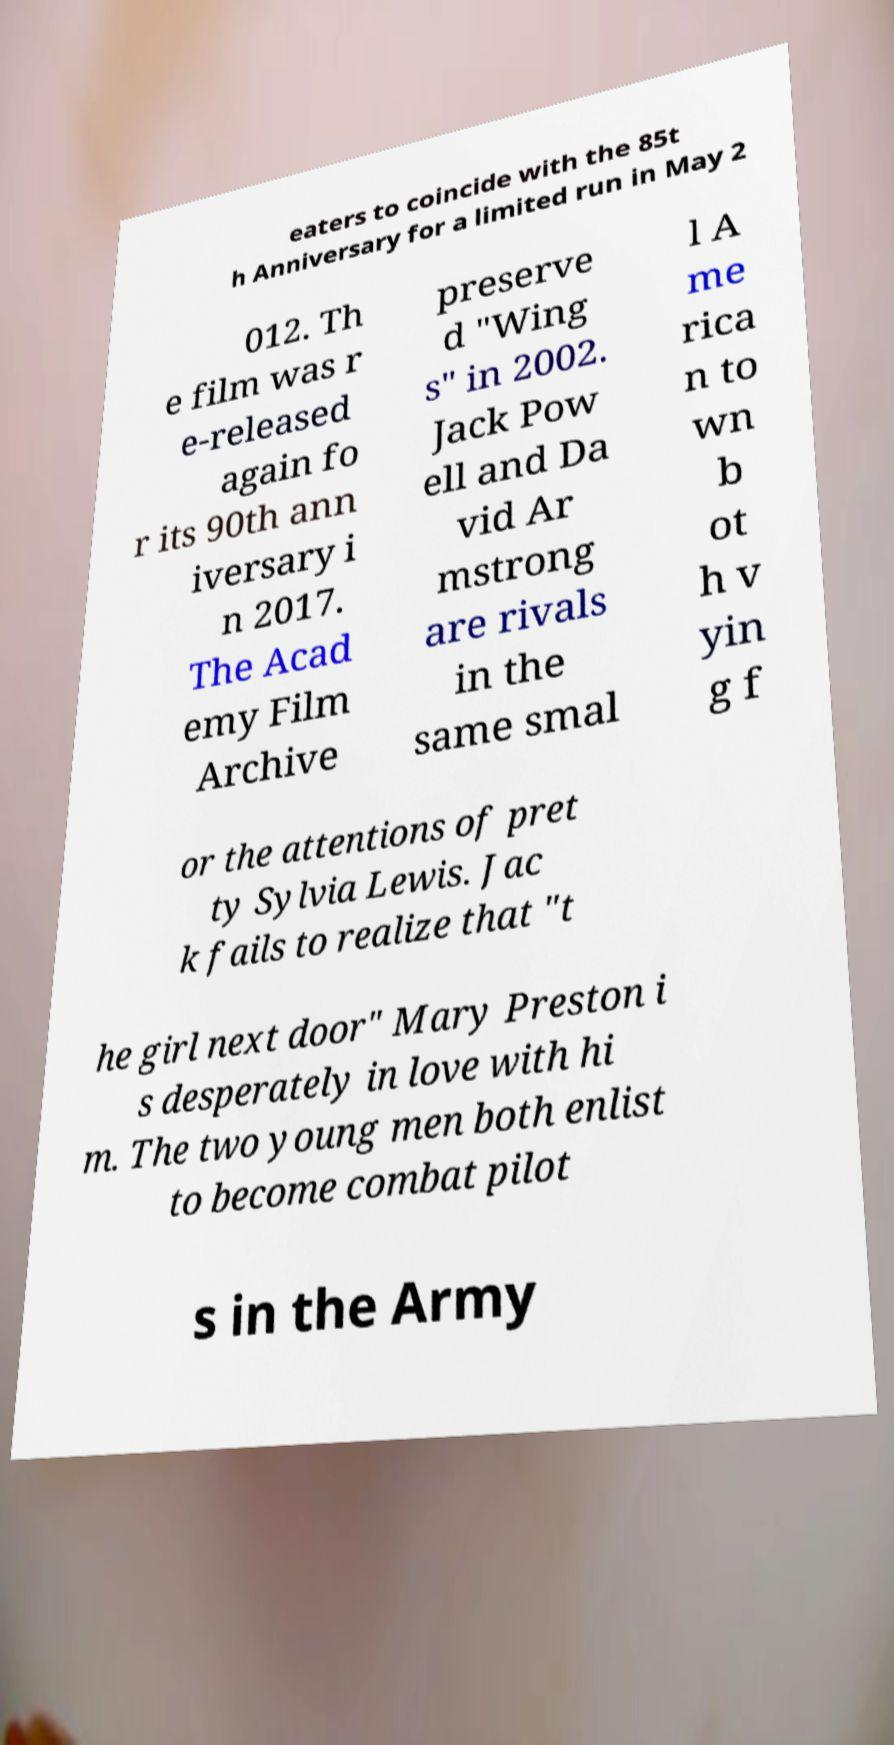What messages or text are displayed in this image? I need them in a readable, typed format. eaters to coincide with the 85t h Anniversary for a limited run in May 2 012. Th e film was r e-released again fo r its 90th ann iversary i n 2017. The Acad emy Film Archive preserve d "Wing s" in 2002. Jack Pow ell and Da vid Ar mstrong are rivals in the same smal l A me rica n to wn b ot h v yin g f or the attentions of pret ty Sylvia Lewis. Jac k fails to realize that "t he girl next door" Mary Preston i s desperately in love with hi m. The two young men both enlist to become combat pilot s in the Army 